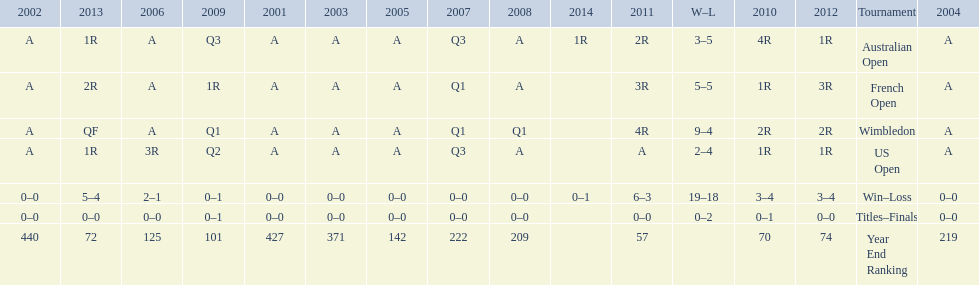Can you give me this table as a dict? {'header': ['2002', '2013', '2006', '2009', '2001', '2003', '2005', '2007', '2008', '2014', '2011', 'W–L', '2010', '2012', 'Tournament', '2004'], 'rows': [['A', '1R', 'A', 'Q3', 'A', 'A', 'A', 'Q3', 'A', '1R', '2R', '3–5', '4R', '1R', 'Australian Open', 'A'], ['A', '2R', 'A', '1R', 'A', 'A', 'A', 'Q1', 'A', '', '3R', '5–5', '1R', '3R', 'French Open', 'A'], ['A', 'QF', 'A', 'Q1', 'A', 'A', 'A', 'Q1', 'Q1', '', '4R', '9–4', '2R', '2R', 'Wimbledon', 'A'], ['A', '1R', '3R', 'Q2', 'A', 'A', 'A', 'Q3', 'A', '', 'A', '2–4', '1R', '1R', 'US Open', 'A'], ['0–0', '5–4', '2–1', '0–1', '0–0', '0–0', '0–0', '0–0', '0–0', '0–1', '6–3', '19–18', '3–4', '3–4', 'Win–Loss', '0–0'], ['0–0', '0–0', '0–0', '0–1', '0–0', '0–0', '0–0', '0–0', '0–0', '', '0–0', '0–2', '0–1', '0–0', 'Titles–Finals', '0–0'], ['440', '72', '125', '101', '427', '371', '142', '222', '209', '', '57', '', '70', '74', 'Year End Ranking', '219']]} In which years were there only 1 loss? 2006, 2009, 2014. 